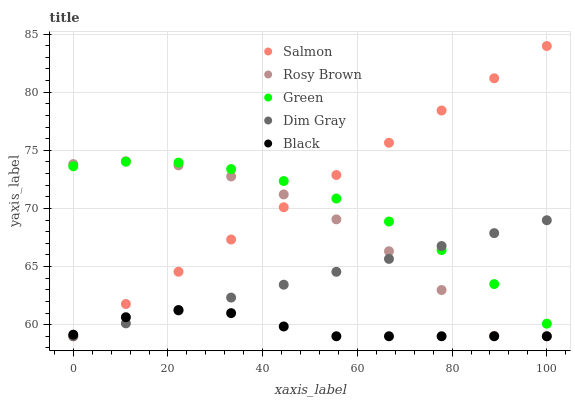Does Black have the minimum area under the curve?
Answer yes or no. Yes. Does Salmon have the maximum area under the curve?
Answer yes or no. Yes. Does Dim Gray have the minimum area under the curve?
Answer yes or no. No. Does Dim Gray have the maximum area under the curve?
Answer yes or no. No. Is Dim Gray the smoothest?
Answer yes or no. Yes. Is Rosy Brown the roughest?
Answer yes or no. Yes. Is Rosy Brown the smoothest?
Answer yes or no. No. Is Dim Gray the roughest?
Answer yes or no. No. Does Dim Gray have the lowest value?
Answer yes or no. Yes. Does Salmon have the highest value?
Answer yes or no. Yes. Does Dim Gray have the highest value?
Answer yes or no. No. Is Black less than Green?
Answer yes or no. Yes. Is Green greater than Black?
Answer yes or no. Yes. Does Salmon intersect Black?
Answer yes or no. Yes. Is Salmon less than Black?
Answer yes or no. No. Is Salmon greater than Black?
Answer yes or no. No. Does Black intersect Green?
Answer yes or no. No. 